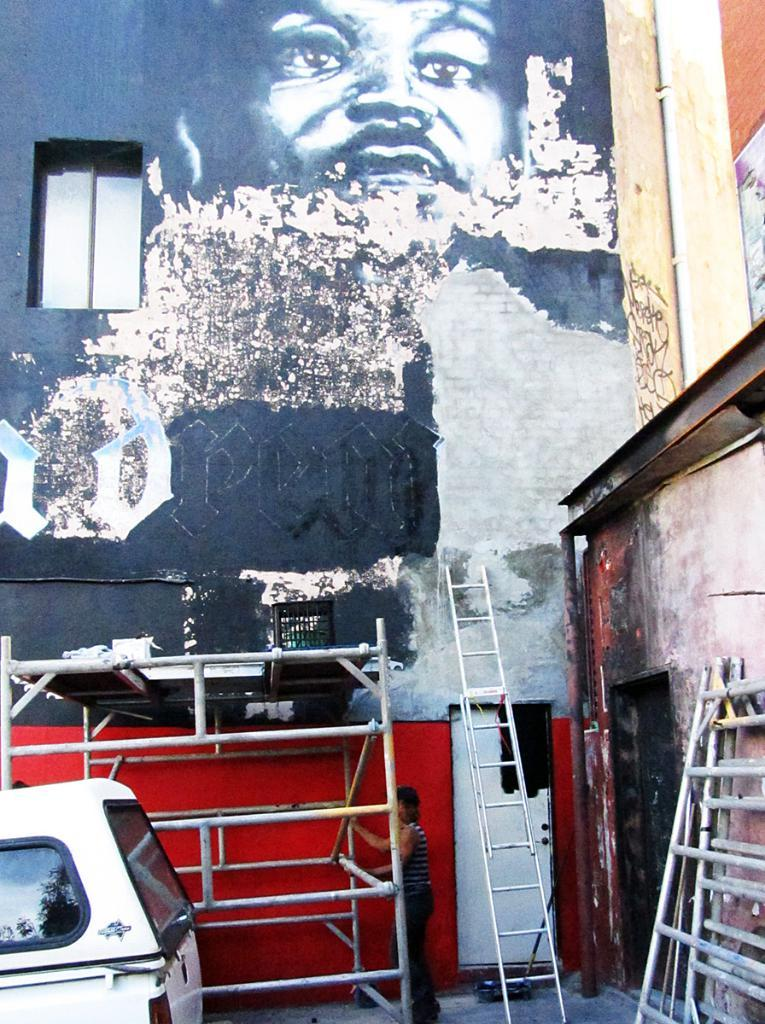What is on the building in the image? There is a painting on the building. What objects are at the bottom of the image? There are ladders at the bottom of the image. What type of transportation is in the image? There is a vehicle in the image. Can you describe the person in the image? There is a person standing in the image. What type of oatmeal is being advertised in the painting on the building? There is no oatmeal or advertisement present in the painting on the building; it is a regular painting. What gardening tool is being used by the person in the image? There is no gardening tool, such as a spade, present in the image; the person is simply standing. 